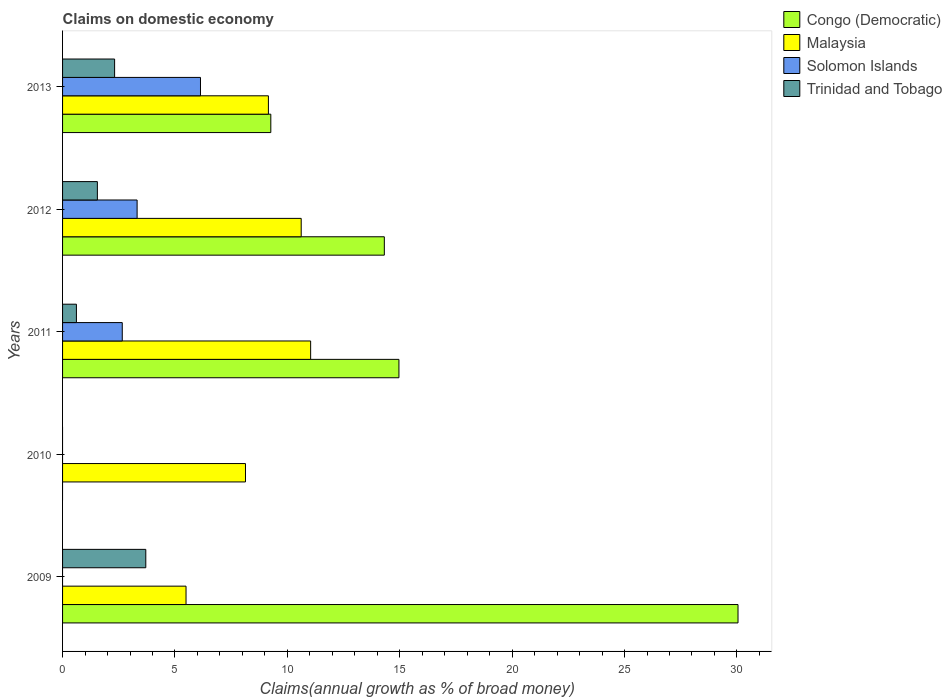How many bars are there on the 4th tick from the top?
Keep it short and to the point. 1. How many bars are there on the 3rd tick from the bottom?
Your response must be concise. 4. What is the label of the 5th group of bars from the top?
Your answer should be very brief. 2009. In how many cases, is the number of bars for a given year not equal to the number of legend labels?
Your answer should be compact. 2. What is the percentage of broad money claimed on domestic economy in Trinidad and Tobago in 2012?
Keep it short and to the point. 1.55. Across all years, what is the maximum percentage of broad money claimed on domestic economy in Malaysia?
Your answer should be compact. 11.04. In which year was the percentage of broad money claimed on domestic economy in Solomon Islands maximum?
Ensure brevity in your answer.  2013. What is the total percentage of broad money claimed on domestic economy in Solomon Islands in the graph?
Provide a short and direct response. 12.11. What is the difference between the percentage of broad money claimed on domestic economy in Trinidad and Tobago in 2009 and that in 2013?
Keep it short and to the point. 1.39. What is the difference between the percentage of broad money claimed on domestic economy in Congo (Democratic) in 2011 and the percentage of broad money claimed on domestic economy in Solomon Islands in 2012?
Give a very brief answer. 11.65. What is the average percentage of broad money claimed on domestic economy in Malaysia per year?
Provide a short and direct response. 8.89. In the year 2012, what is the difference between the percentage of broad money claimed on domestic economy in Solomon Islands and percentage of broad money claimed on domestic economy in Congo (Democratic)?
Your answer should be very brief. -11. In how many years, is the percentage of broad money claimed on domestic economy in Solomon Islands greater than 7 %?
Your answer should be compact. 0. What is the ratio of the percentage of broad money claimed on domestic economy in Malaysia in 2009 to that in 2011?
Provide a short and direct response. 0.5. Is the difference between the percentage of broad money claimed on domestic economy in Solomon Islands in 2011 and 2012 greater than the difference between the percentage of broad money claimed on domestic economy in Congo (Democratic) in 2011 and 2012?
Offer a very short reply. No. What is the difference between the highest and the second highest percentage of broad money claimed on domestic economy in Solomon Islands?
Offer a terse response. 2.82. What is the difference between the highest and the lowest percentage of broad money claimed on domestic economy in Congo (Democratic)?
Offer a terse response. 30.05. In how many years, is the percentage of broad money claimed on domestic economy in Solomon Islands greater than the average percentage of broad money claimed on domestic economy in Solomon Islands taken over all years?
Ensure brevity in your answer.  3. Are all the bars in the graph horizontal?
Make the answer very short. Yes. How many years are there in the graph?
Offer a very short reply. 5. What is the difference between two consecutive major ticks on the X-axis?
Provide a succinct answer. 5. Are the values on the major ticks of X-axis written in scientific E-notation?
Offer a terse response. No. How many legend labels are there?
Ensure brevity in your answer.  4. How are the legend labels stacked?
Keep it short and to the point. Vertical. What is the title of the graph?
Offer a very short reply. Claims on domestic economy. What is the label or title of the X-axis?
Your answer should be compact. Claims(annual growth as % of broad money). What is the label or title of the Y-axis?
Your response must be concise. Years. What is the Claims(annual growth as % of broad money) in Congo (Democratic) in 2009?
Your response must be concise. 30.05. What is the Claims(annual growth as % of broad money) in Malaysia in 2009?
Offer a very short reply. 5.49. What is the Claims(annual growth as % of broad money) of Solomon Islands in 2009?
Give a very brief answer. 0. What is the Claims(annual growth as % of broad money) of Trinidad and Tobago in 2009?
Offer a terse response. 3.7. What is the Claims(annual growth as % of broad money) in Congo (Democratic) in 2010?
Offer a terse response. 0. What is the Claims(annual growth as % of broad money) in Malaysia in 2010?
Your response must be concise. 8.14. What is the Claims(annual growth as % of broad money) in Solomon Islands in 2010?
Your answer should be compact. 0. What is the Claims(annual growth as % of broad money) of Trinidad and Tobago in 2010?
Ensure brevity in your answer.  0. What is the Claims(annual growth as % of broad money) in Congo (Democratic) in 2011?
Give a very brief answer. 14.96. What is the Claims(annual growth as % of broad money) in Malaysia in 2011?
Your answer should be compact. 11.04. What is the Claims(annual growth as % of broad money) in Solomon Islands in 2011?
Make the answer very short. 2.66. What is the Claims(annual growth as % of broad money) of Trinidad and Tobago in 2011?
Offer a terse response. 0.62. What is the Claims(annual growth as % of broad money) of Congo (Democratic) in 2012?
Provide a succinct answer. 14.31. What is the Claims(annual growth as % of broad money) of Malaysia in 2012?
Offer a terse response. 10.62. What is the Claims(annual growth as % of broad money) of Solomon Islands in 2012?
Give a very brief answer. 3.32. What is the Claims(annual growth as % of broad money) of Trinidad and Tobago in 2012?
Give a very brief answer. 1.55. What is the Claims(annual growth as % of broad money) in Congo (Democratic) in 2013?
Offer a terse response. 9.26. What is the Claims(annual growth as % of broad money) of Malaysia in 2013?
Keep it short and to the point. 9.16. What is the Claims(annual growth as % of broad money) of Solomon Islands in 2013?
Your answer should be very brief. 6.14. What is the Claims(annual growth as % of broad money) of Trinidad and Tobago in 2013?
Your answer should be very brief. 2.32. Across all years, what is the maximum Claims(annual growth as % of broad money) of Congo (Democratic)?
Provide a succinct answer. 30.05. Across all years, what is the maximum Claims(annual growth as % of broad money) of Malaysia?
Give a very brief answer. 11.04. Across all years, what is the maximum Claims(annual growth as % of broad money) of Solomon Islands?
Keep it short and to the point. 6.14. Across all years, what is the maximum Claims(annual growth as % of broad money) in Trinidad and Tobago?
Give a very brief answer. 3.7. Across all years, what is the minimum Claims(annual growth as % of broad money) of Congo (Democratic)?
Provide a short and direct response. 0. Across all years, what is the minimum Claims(annual growth as % of broad money) of Malaysia?
Give a very brief answer. 5.49. Across all years, what is the minimum Claims(annual growth as % of broad money) in Trinidad and Tobago?
Keep it short and to the point. 0. What is the total Claims(annual growth as % of broad money) in Congo (Democratic) in the graph?
Keep it short and to the point. 68.59. What is the total Claims(annual growth as % of broad money) in Malaysia in the graph?
Give a very brief answer. 44.44. What is the total Claims(annual growth as % of broad money) in Solomon Islands in the graph?
Ensure brevity in your answer.  12.11. What is the total Claims(annual growth as % of broad money) of Trinidad and Tobago in the graph?
Ensure brevity in your answer.  8.18. What is the difference between the Claims(annual growth as % of broad money) of Malaysia in 2009 and that in 2010?
Provide a succinct answer. -2.64. What is the difference between the Claims(annual growth as % of broad money) of Congo (Democratic) in 2009 and that in 2011?
Provide a succinct answer. 15.08. What is the difference between the Claims(annual growth as % of broad money) of Malaysia in 2009 and that in 2011?
Ensure brevity in your answer.  -5.54. What is the difference between the Claims(annual growth as % of broad money) in Trinidad and Tobago in 2009 and that in 2011?
Ensure brevity in your answer.  3.09. What is the difference between the Claims(annual growth as % of broad money) of Congo (Democratic) in 2009 and that in 2012?
Offer a terse response. 15.73. What is the difference between the Claims(annual growth as % of broad money) of Malaysia in 2009 and that in 2012?
Keep it short and to the point. -5.12. What is the difference between the Claims(annual growth as % of broad money) in Trinidad and Tobago in 2009 and that in 2012?
Offer a terse response. 2.15. What is the difference between the Claims(annual growth as % of broad money) in Congo (Democratic) in 2009 and that in 2013?
Your answer should be very brief. 20.78. What is the difference between the Claims(annual growth as % of broad money) of Malaysia in 2009 and that in 2013?
Make the answer very short. -3.66. What is the difference between the Claims(annual growth as % of broad money) of Trinidad and Tobago in 2009 and that in 2013?
Ensure brevity in your answer.  1.39. What is the difference between the Claims(annual growth as % of broad money) of Malaysia in 2010 and that in 2011?
Make the answer very short. -2.9. What is the difference between the Claims(annual growth as % of broad money) in Malaysia in 2010 and that in 2012?
Your answer should be compact. -2.48. What is the difference between the Claims(annual growth as % of broad money) in Malaysia in 2010 and that in 2013?
Provide a short and direct response. -1.02. What is the difference between the Claims(annual growth as % of broad money) of Congo (Democratic) in 2011 and that in 2012?
Your answer should be compact. 0.65. What is the difference between the Claims(annual growth as % of broad money) of Malaysia in 2011 and that in 2012?
Ensure brevity in your answer.  0.42. What is the difference between the Claims(annual growth as % of broad money) in Solomon Islands in 2011 and that in 2012?
Ensure brevity in your answer.  -0.66. What is the difference between the Claims(annual growth as % of broad money) in Trinidad and Tobago in 2011 and that in 2012?
Offer a very short reply. -0.93. What is the difference between the Claims(annual growth as % of broad money) in Congo (Democratic) in 2011 and that in 2013?
Your answer should be compact. 5.7. What is the difference between the Claims(annual growth as % of broad money) in Malaysia in 2011 and that in 2013?
Offer a very short reply. 1.88. What is the difference between the Claims(annual growth as % of broad money) of Solomon Islands in 2011 and that in 2013?
Ensure brevity in your answer.  -3.48. What is the difference between the Claims(annual growth as % of broad money) of Trinidad and Tobago in 2011 and that in 2013?
Make the answer very short. -1.7. What is the difference between the Claims(annual growth as % of broad money) of Congo (Democratic) in 2012 and that in 2013?
Provide a short and direct response. 5.05. What is the difference between the Claims(annual growth as % of broad money) of Malaysia in 2012 and that in 2013?
Offer a very short reply. 1.46. What is the difference between the Claims(annual growth as % of broad money) of Solomon Islands in 2012 and that in 2013?
Give a very brief answer. -2.82. What is the difference between the Claims(annual growth as % of broad money) of Trinidad and Tobago in 2012 and that in 2013?
Provide a succinct answer. -0.77. What is the difference between the Claims(annual growth as % of broad money) of Congo (Democratic) in 2009 and the Claims(annual growth as % of broad money) of Malaysia in 2010?
Your answer should be compact. 21.91. What is the difference between the Claims(annual growth as % of broad money) in Congo (Democratic) in 2009 and the Claims(annual growth as % of broad money) in Malaysia in 2011?
Keep it short and to the point. 19.01. What is the difference between the Claims(annual growth as % of broad money) of Congo (Democratic) in 2009 and the Claims(annual growth as % of broad money) of Solomon Islands in 2011?
Offer a terse response. 27.39. What is the difference between the Claims(annual growth as % of broad money) of Congo (Democratic) in 2009 and the Claims(annual growth as % of broad money) of Trinidad and Tobago in 2011?
Your answer should be very brief. 29.43. What is the difference between the Claims(annual growth as % of broad money) of Malaysia in 2009 and the Claims(annual growth as % of broad money) of Solomon Islands in 2011?
Keep it short and to the point. 2.84. What is the difference between the Claims(annual growth as % of broad money) in Malaysia in 2009 and the Claims(annual growth as % of broad money) in Trinidad and Tobago in 2011?
Keep it short and to the point. 4.88. What is the difference between the Claims(annual growth as % of broad money) of Congo (Democratic) in 2009 and the Claims(annual growth as % of broad money) of Malaysia in 2012?
Your answer should be compact. 19.43. What is the difference between the Claims(annual growth as % of broad money) of Congo (Democratic) in 2009 and the Claims(annual growth as % of broad money) of Solomon Islands in 2012?
Give a very brief answer. 26.73. What is the difference between the Claims(annual growth as % of broad money) in Congo (Democratic) in 2009 and the Claims(annual growth as % of broad money) in Trinidad and Tobago in 2012?
Give a very brief answer. 28.5. What is the difference between the Claims(annual growth as % of broad money) in Malaysia in 2009 and the Claims(annual growth as % of broad money) in Solomon Islands in 2012?
Provide a short and direct response. 2.18. What is the difference between the Claims(annual growth as % of broad money) in Malaysia in 2009 and the Claims(annual growth as % of broad money) in Trinidad and Tobago in 2012?
Your answer should be compact. 3.94. What is the difference between the Claims(annual growth as % of broad money) of Congo (Democratic) in 2009 and the Claims(annual growth as % of broad money) of Malaysia in 2013?
Provide a succinct answer. 20.89. What is the difference between the Claims(annual growth as % of broad money) of Congo (Democratic) in 2009 and the Claims(annual growth as % of broad money) of Solomon Islands in 2013?
Offer a terse response. 23.91. What is the difference between the Claims(annual growth as % of broad money) of Congo (Democratic) in 2009 and the Claims(annual growth as % of broad money) of Trinidad and Tobago in 2013?
Provide a succinct answer. 27.73. What is the difference between the Claims(annual growth as % of broad money) in Malaysia in 2009 and the Claims(annual growth as % of broad money) in Solomon Islands in 2013?
Provide a succinct answer. -0.64. What is the difference between the Claims(annual growth as % of broad money) of Malaysia in 2009 and the Claims(annual growth as % of broad money) of Trinidad and Tobago in 2013?
Your response must be concise. 3.18. What is the difference between the Claims(annual growth as % of broad money) in Malaysia in 2010 and the Claims(annual growth as % of broad money) in Solomon Islands in 2011?
Keep it short and to the point. 5.48. What is the difference between the Claims(annual growth as % of broad money) in Malaysia in 2010 and the Claims(annual growth as % of broad money) in Trinidad and Tobago in 2011?
Your response must be concise. 7.52. What is the difference between the Claims(annual growth as % of broad money) in Malaysia in 2010 and the Claims(annual growth as % of broad money) in Solomon Islands in 2012?
Your answer should be very brief. 4.82. What is the difference between the Claims(annual growth as % of broad money) of Malaysia in 2010 and the Claims(annual growth as % of broad money) of Trinidad and Tobago in 2012?
Ensure brevity in your answer.  6.59. What is the difference between the Claims(annual growth as % of broad money) in Malaysia in 2010 and the Claims(annual growth as % of broad money) in Solomon Islands in 2013?
Your answer should be very brief. 2. What is the difference between the Claims(annual growth as % of broad money) in Malaysia in 2010 and the Claims(annual growth as % of broad money) in Trinidad and Tobago in 2013?
Offer a very short reply. 5.82. What is the difference between the Claims(annual growth as % of broad money) in Congo (Democratic) in 2011 and the Claims(annual growth as % of broad money) in Malaysia in 2012?
Your response must be concise. 4.35. What is the difference between the Claims(annual growth as % of broad money) in Congo (Democratic) in 2011 and the Claims(annual growth as % of broad money) in Solomon Islands in 2012?
Your answer should be compact. 11.65. What is the difference between the Claims(annual growth as % of broad money) of Congo (Democratic) in 2011 and the Claims(annual growth as % of broad money) of Trinidad and Tobago in 2012?
Give a very brief answer. 13.42. What is the difference between the Claims(annual growth as % of broad money) of Malaysia in 2011 and the Claims(annual growth as % of broad money) of Solomon Islands in 2012?
Offer a very short reply. 7.72. What is the difference between the Claims(annual growth as % of broad money) of Malaysia in 2011 and the Claims(annual growth as % of broad money) of Trinidad and Tobago in 2012?
Your response must be concise. 9.49. What is the difference between the Claims(annual growth as % of broad money) of Solomon Islands in 2011 and the Claims(annual growth as % of broad money) of Trinidad and Tobago in 2012?
Provide a short and direct response. 1.11. What is the difference between the Claims(annual growth as % of broad money) in Congo (Democratic) in 2011 and the Claims(annual growth as % of broad money) in Malaysia in 2013?
Your answer should be compact. 5.81. What is the difference between the Claims(annual growth as % of broad money) in Congo (Democratic) in 2011 and the Claims(annual growth as % of broad money) in Solomon Islands in 2013?
Provide a succinct answer. 8.83. What is the difference between the Claims(annual growth as % of broad money) in Congo (Democratic) in 2011 and the Claims(annual growth as % of broad money) in Trinidad and Tobago in 2013?
Provide a short and direct response. 12.65. What is the difference between the Claims(annual growth as % of broad money) in Malaysia in 2011 and the Claims(annual growth as % of broad money) in Solomon Islands in 2013?
Your answer should be compact. 4.9. What is the difference between the Claims(annual growth as % of broad money) of Malaysia in 2011 and the Claims(annual growth as % of broad money) of Trinidad and Tobago in 2013?
Provide a succinct answer. 8.72. What is the difference between the Claims(annual growth as % of broad money) of Solomon Islands in 2011 and the Claims(annual growth as % of broad money) of Trinidad and Tobago in 2013?
Your answer should be compact. 0.34. What is the difference between the Claims(annual growth as % of broad money) in Congo (Democratic) in 2012 and the Claims(annual growth as % of broad money) in Malaysia in 2013?
Provide a succinct answer. 5.16. What is the difference between the Claims(annual growth as % of broad money) of Congo (Democratic) in 2012 and the Claims(annual growth as % of broad money) of Solomon Islands in 2013?
Your answer should be compact. 8.18. What is the difference between the Claims(annual growth as % of broad money) in Congo (Democratic) in 2012 and the Claims(annual growth as % of broad money) in Trinidad and Tobago in 2013?
Provide a short and direct response. 12. What is the difference between the Claims(annual growth as % of broad money) of Malaysia in 2012 and the Claims(annual growth as % of broad money) of Solomon Islands in 2013?
Make the answer very short. 4.48. What is the difference between the Claims(annual growth as % of broad money) of Malaysia in 2012 and the Claims(annual growth as % of broad money) of Trinidad and Tobago in 2013?
Offer a very short reply. 8.3. What is the average Claims(annual growth as % of broad money) of Congo (Democratic) per year?
Ensure brevity in your answer.  13.72. What is the average Claims(annual growth as % of broad money) in Malaysia per year?
Make the answer very short. 8.89. What is the average Claims(annual growth as % of broad money) in Solomon Islands per year?
Keep it short and to the point. 2.42. What is the average Claims(annual growth as % of broad money) of Trinidad and Tobago per year?
Make the answer very short. 1.64. In the year 2009, what is the difference between the Claims(annual growth as % of broad money) in Congo (Democratic) and Claims(annual growth as % of broad money) in Malaysia?
Your response must be concise. 24.56. In the year 2009, what is the difference between the Claims(annual growth as % of broad money) in Congo (Democratic) and Claims(annual growth as % of broad money) in Trinidad and Tobago?
Offer a very short reply. 26.35. In the year 2009, what is the difference between the Claims(annual growth as % of broad money) in Malaysia and Claims(annual growth as % of broad money) in Trinidad and Tobago?
Give a very brief answer. 1.79. In the year 2011, what is the difference between the Claims(annual growth as % of broad money) in Congo (Democratic) and Claims(annual growth as % of broad money) in Malaysia?
Keep it short and to the point. 3.93. In the year 2011, what is the difference between the Claims(annual growth as % of broad money) in Congo (Democratic) and Claims(annual growth as % of broad money) in Solomon Islands?
Provide a succinct answer. 12.31. In the year 2011, what is the difference between the Claims(annual growth as % of broad money) in Congo (Democratic) and Claims(annual growth as % of broad money) in Trinidad and Tobago?
Offer a terse response. 14.35. In the year 2011, what is the difference between the Claims(annual growth as % of broad money) of Malaysia and Claims(annual growth as % of broad money) of Solomon Islands?
Your answer should be very brief. 8.38. In the year 2011, what is the difference between the Claims(annual growth as % of broad money) of Malaysia and Claims(annual growth as % of broad money) of Trinidad and Tobago?
Provide a short and direct response. 10.42. In the year 2011, what is the difference between the Claims(annual growth as % of broad money) in Solomon Islands and Claims(annual growth as % of broad money) in Trinidad and Tobago?
Offer a very short reply. 2.04. In the year 2012, what is the difference between the Claims(annual growth as % of broad money) of Congo (Democratic) and Claims(annual growth as % of broad money) of Malaysia?
Provide a short and direct response. 3.7. In the year 2012, what is the difference between the Claims(annual growth as % of broad money) in Congo (Democratic) and Claims(annual growth as % of broad money) in Solomon Islands?
Keep it short and to the point. 11. In the year 2012, what is the difference between the Claims(annual growth as % of broad money) in Congo (Democratic) and Claims(annual growth as % of broad money) in Trinidad and Tobago?
Make the answer very short. 12.77. In the year 2012, what is the difference between the Claims(annual growth as % of broad money) of Malaysia and Claims(annual growth as % of broad money) of Solomon Islands?
Your response must be concise. 7.3. In the year 2012, what is the difference between the Claims(annual growth as % of broad money) of Malaysia and Claims(annual growth as % of broad money) of Trinidad and Tobago?
Offer a very short reply. 9.07. In the year 2012, what is the difference between the Claims(annual growth as % of broad money) in Solomon Islands and Claims(annual growth as % of broad money) in Trinidad and Tobago?
Keep it short and to the point. 1.77. In the year 2013, what is the difference between the Claims(annual growth as % of broad money) in Congo (Democratic) and Claims(annual growth as % of broad money) in Malaysia?
Your answer should be compact. 0.11. In the year 2013, what is the difference between the Claims(annual growth as % of broad money) in Congo (Democratic) and Claims(annual growth as % of broad money) in Solomon Islands?
Your answer should be compact. 3.13. In the year 2013, what is the difference between the Claims(annual growth as % of broad money) in Congo (Democratic) and Claims(annual growth as % of broad money) in Trinidad and Tobago?
Give a very brief answer. 6.95. In the year 2013, what is the difference between the Claims(annual growth as % of broad money) in Malaysia and Claims(annual growth as % of broad money) in Solomon Islands?
Your response must be concise. 3.02. In the year 2013, what is the difference between the Claims(annual growth as % of broad money) of Malaysia and Claims(annual growth as % of broad money) of Trinidad and Tobago?
Your response must be concise. 6.84. In the year 2013, what is the difference between the Claims(annual growth as % of broad money) in Solomon Islands and Claims(annual growth as % of broad money) in Trinidad and Tobago?
Offer a very short reply. 3.82. What is the ratio of the Claims(annual growth as % of broad money) of Malaysia in 2009 to that in 2010?
Give a very brief answer. 0.68. What is the ratio of the Claims(annual growth as % of broad money) of Congo (Democratic) in 2009 to that in 2011?
Keep it short and to the point. 2.01. What is the ratio of the Claims(annual growth as % of broad money) of Malaysia in 2009 to that in 2011?
Keep it short and to the point. 0.5. What is the ratio of the Claims(annual growth as % of broad money) of Trinidad and Tobago in 2009 to that in 2011?
Your answer should be compact. 6.01. What is the ratio of the Claims(annual growth as % of broad money) of Congo (Democratic) in 2009 to that in 2012?
Provide a succinct answer. 2.1. What is the ratio of the Claims(annual growth as % of broad money) of Malaysia in 2009 to that in 2012?
Offer a very short reply. 0.52. What is the ratio of the Claims(annual growth as % of broad money) of Trinidad and Tobago in 2009 to that in 2012?
Offer a terse response. 2.39. What is the ratio of the Claims(annual growth as % of broad money) of Congo (Democratic) in 2009 to that in 2013?
Ensure brevity in your answer.  3.24. What is the ratio of the Claims(annual growth as % of broad money) in Malaysia in 2009 to that in 2013?
Offer a very short reply. 0.6. What is the ratio of the Claims(annual growth as % of broad money) in Trinidad and Tobago in 2009 to that in 2013?
Provide a short and direct response. 1.6. What is the ratio of the Claims(annual growth as % of broad money) of Malaysia in 2010 to that in 2011?
Your answer should be compact. 0.74. What is the ratio of the Claims(annual growth as % of broad money) of Malaysia in 2010 to that in 2012?
Give a very brief answer. 0.77. What is the ratio of the Claims(annual growth as % of broad money) in Malaysia in 2010 to that in 2013?
Ensure brevity in your answer.  0.89. What is the ratio of the Claims(annual growth as % of broad money) of Congo (Democratic) in 2011 to that in 2012?
Your answer should be compact. 1.05. What is the ratio of the Claims(annual growth as % of broad money) of Malaysia in 2011 to that in 2012?
Provide a short and direct response. 1.04. What is the ratio of the Claims(annual growth as % of broad money) of Solomon Islands in 2011 to that in 2012?
Keep it short and to the point. 0.8. What is the ratio of the Claims(annual growth as % of broad money) of Trinidad and Tobago in 2011 to that in 2012?
Your answer should be compact. 0.4. What is the ratio of the Claims(annual growth as % of broad money) in Congo (Democratic) in 2011 to that in 2013?
Provide a succinct answer. 1.62. What is the ratio of the Claims(annual growth as % of broad money) of Malaysia in 2011 to that in 2013?
Make the answer very short. 1.21. What is the ratio of the Claims(annual growth as % of broad money) of Solomon Islands in 2011 to that in 2013?
Provide a short and direct response. 0.43. What is the ratio of the Claims(annual growth as % of broad money) of Trinidad and Tobago in 2011 to that in 2013?
Your response must be concise. 0.27. What is the ratio of the Claims(annual growth as % of broad money) in Congo (Democratic) in 2012 to that in 2013?
Your answer should be compact. 1.55. What is the ratio of the Claims(annual growth as % of broad money) of Malaysia in 2012 to that in 2013?
Your answer should be compact. 1.16. What is the ratio of the Claims(annual growth as % of broad money) of Solomon Islands in 2012 to that in 2013?
Your answer should be compact. 0.54. What is the ratio of the Claims(annual growth as % of broad money) in Trinidad and Tobago in 2012 to that in 2013?
Your response must be concise. 0.67. What is the difference between the highest and the second highest Claims(annual growth as % of broad money) of Congo (Democratic)?
Your answer should be very brief. 15.08. What is the difference between the highest and the second highest Claims(annual growth as % of broad money) of Malaysia?
Your answer should be compact. 0.42. What is the difference between the highest and the second highest Claims(annual growth as % of broad money) in Solomon Islands?
Keep it short and to the point. 2.82. What is the difference between the highest and the second highest Claims(annual growth as % of broad money) of Trinidad and Tobago?
Provide a succinct answer. 1.39. What is the difference between the highest and the lowest Claims(annual growth as % of broad money) of Congo (Democratic)?
Ensure brevity in your answer.  30.05. What is the difference between the highest and the lowest Claims(annual growth as % of broad money) of Malaysia?
Offer a very short reply. 5.54. What is the difference between the highest and the lowest Claims(annual growth as % of broad money) in Solomon Islands?
Offer a very short reply. 6.14. What is the difference between the highest and the lowest Claims(annual growth as % of broad money) of Trinidad and Tobago?
Provide a succinct answer. 3.7. 